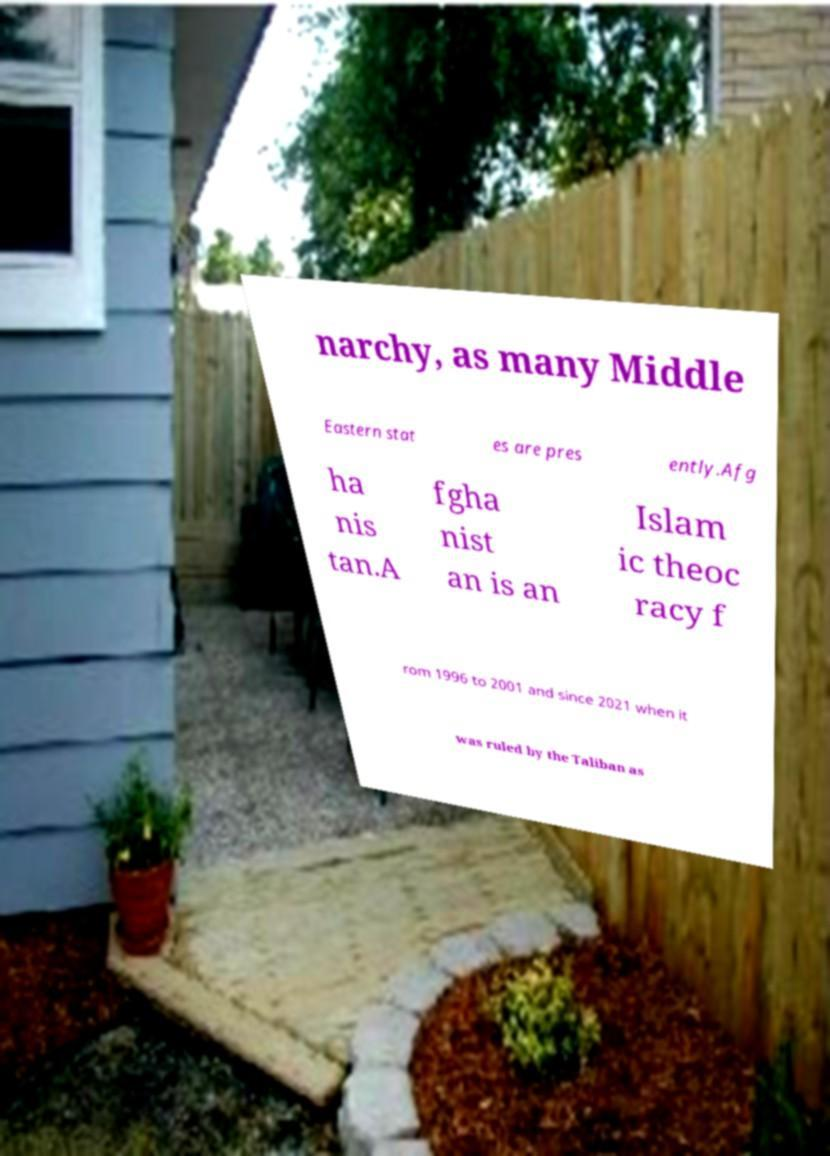Can you read and provide the text displayed in the image?This photo seems to have some interesting text. Can you extract and type it out for me? narchy, as many Middle Eastern stat es are pres ently.Afg ha nis tan.A fgha nist an is an Islam ic theoc racy f rom 1996 to 2001 and since 2021 when it was ruled by the Taliban as 